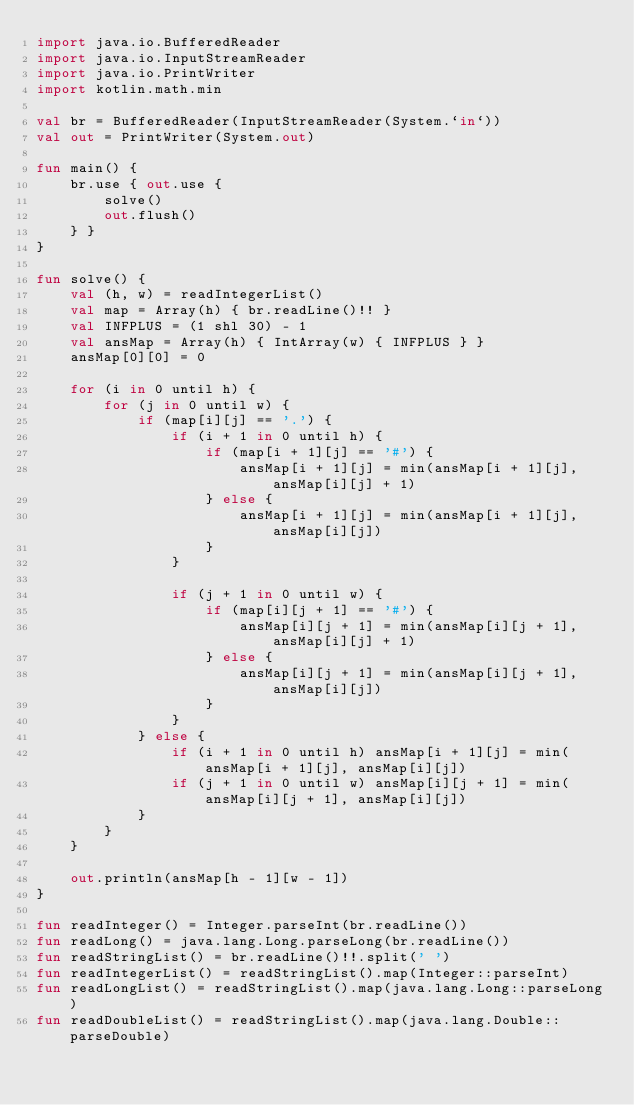Convert code to text. <code><loc_0><loc_0><loc_500><loc_500><_Kotlin_>import java.io.BufferedReader
import java.io.InputStreamReader
import java.io.PrintWriter
import kotlin.math.min

val br = BufferedReader(InputStreamReader(System.`in`))
val out = PrintWriter(System.out)

fun main() {
    br.use { out.use {
        solve()
        out.flush()
    } }
}

fun solve() {
    val (h, w) = readIntegerList()
    val map = Array(h) { br.readLine()!! }
    val INFPLUS = (1 shl 30) - 1
    val ansMap = Array(h) { IntArray(w) { INFPLUS } }
    ansMap[0][0] = 0

    for (i in 0 until h) {
        for (j in 0 until w) {
            if (map[i][j] == '.') {
                if (i + 1 in 0 until h) {
                    if (map[i + 1][j] == '#') {
                        ansMap[i + 1][j] = min(ansMap[i + 1][j], ansMap[i][j] + 1)
                    } else {
                        ansMap[i + 1][j] = min(ansMap[i + 1][j], ansMap[i][j])
                    }
                }
                
                if (j + 1 in 0 until w) {
                    if (map[i][j + 1] == '#') {
                        ansMap[i][j + 1] = min(ansMap[i][j + 1], ansMap[i][j] + 1)
                    } else {
                        ansMap[i][j + 1] = min(ansMap[i][j + 1], ansMap[i][j])
                    }
                }
            } else {
                if (i + 1 in 0 until h) ansMap[i + 1][j] = min(ansMap[i + 1][j], ansMap[i][j])
                if (j + 1 in 0 until w) ansMap[i][j + 1] = min(ansMap[i][j + 1], ansMap[i][j])
            }
        }
    }
    
    out.println(ansMap[h - 1][w - 1])
}

fun readInteger() = Integer.parseInt(br.readLine())
fun readLong() = java.lang.Long.parseLong(br.readLine())
fun readStringList() = br.readLine()!!.split(' ')
fun readIntegerList() = readStringList().map(Integer::parseInt)
fun readLongList() = readStringList().map(java.lang.Long::parseLong)
fun readDoubleList() = readStringList().map(java.lang.Double::parseDouble)
</code> 